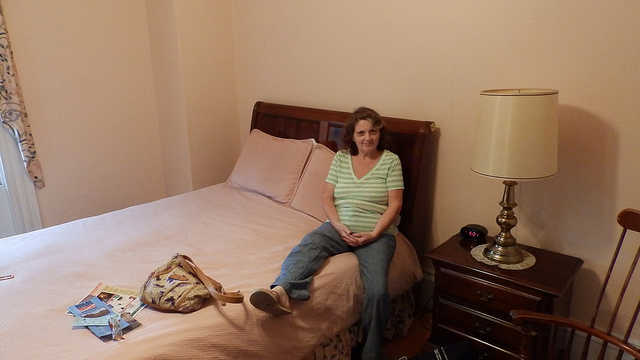Does the room have any personal items that suggest it is often used? Yes, the room has personal touches like a lamp, a digital alarm clock, and magazines, suggesting it is regularly occupied. 